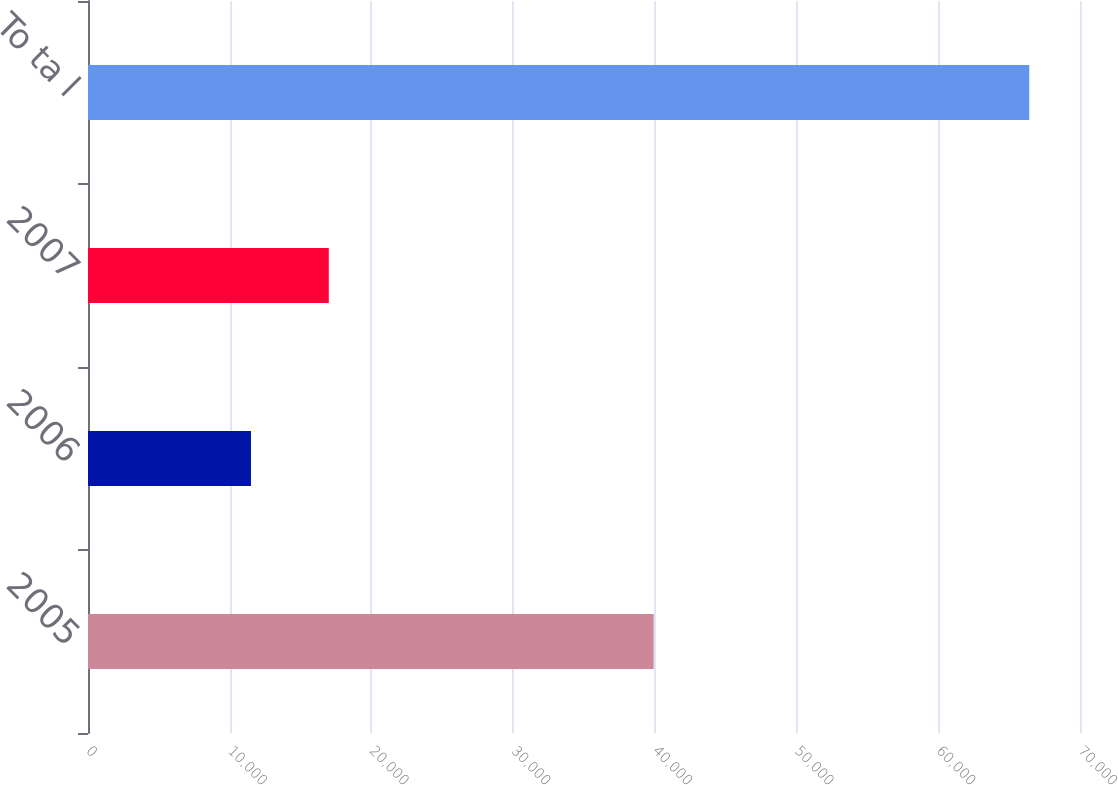Convert chart to OTSL. <chart><loc_0><loc_0><loc_500><loc_500><bar_chart><fcel>2005<fcel>2006<fcel>2007<fcel>To ta l<nl><fcel>39919<fcel>11500<fcel>16991.9<fcel>66419<nl></chart> 